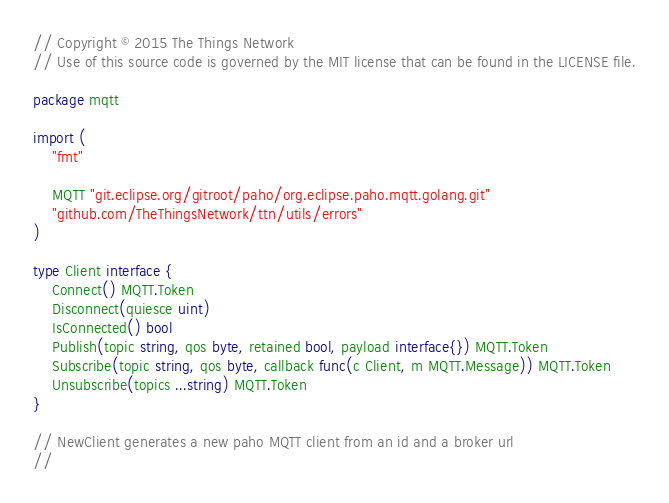<code> <loc_0><loc_0><loc_500><loc_500><_Go_>// Copyright © 2015 The Things Network
// Use of this source code is governed by the MIT license that can be found in the LICENSE file.

package mqtt

import (
	"fmt"

	MQTT "git.eclipse.org/gitroot/paho/org.eclipse.paho.mqtt.golang.git"
	"github.com/TheThingsNetwork/ttn/utils/errors"
)

type Client interface {
	Connect() MQTT.Token
	Disconnect(quiesce uint)
	IsConnected() bool
	Publish(topic string, qos byte, retained bool, payload interface{}) MQTT.Token
	Subscribe(topic string, qos byte, callback func(c Client, m MQTT.Message)) MQTT.Token
	Unsubscribe(topics ...string) MQTT.Token
}

// NewClient generates a new paho MQTT client from an id and a broker url
//</code> 